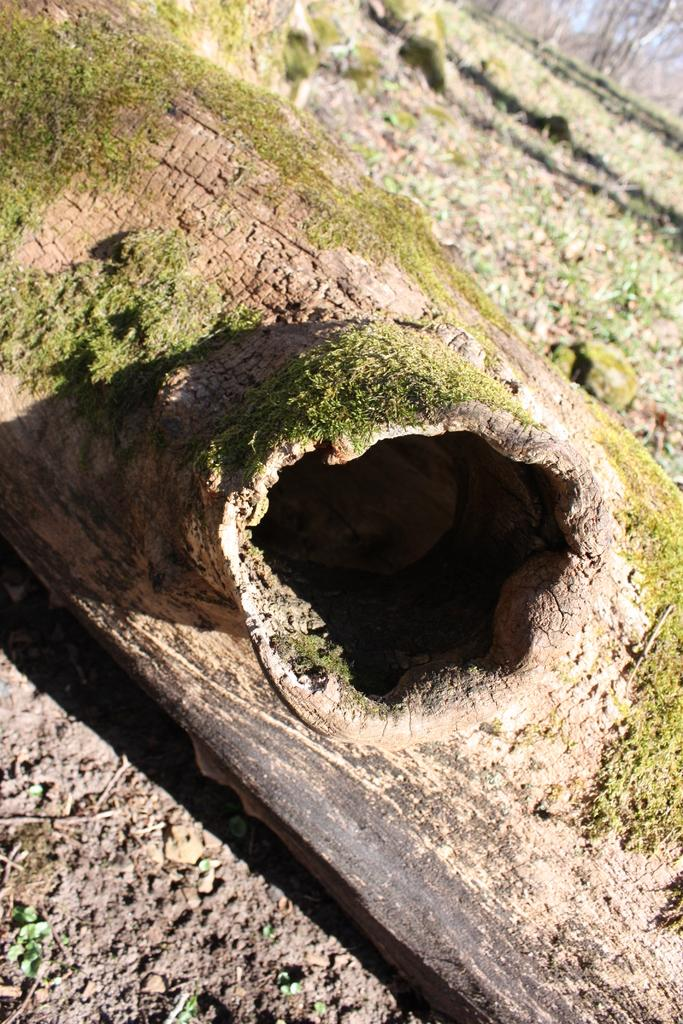What is on the ground in the image? There is a log on the ground in the image. What type of yard work is the maid performing with the angle in the image? There is no yard, maid, or angle present in the image; it only features a log on the ground. 